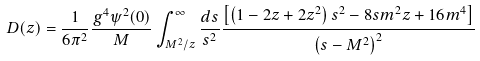<formula> <loc_0><loc_0><loc_500><loc_500>D ( z ) = \frac { 1 } { 6 \pi ^ { 2 } } \frac { g ^ { 4 } \psi ^ { 2 } ( 0 ) } { M } \int ^ { \infty } _ { M ^ { 2 } / z } \frac { d s } { s ^ { 2 } } \frac { \left [ \left ( 1 - 2 z + 2 z ^ { 2 } \right ) s ^ { 2 } - 8 s m ^ { 2 } z + 1 6 m ^ { 4 } \right ] } { \left ( s - M ^ { 2 } \right ) ^ { 2 } }</formula> 